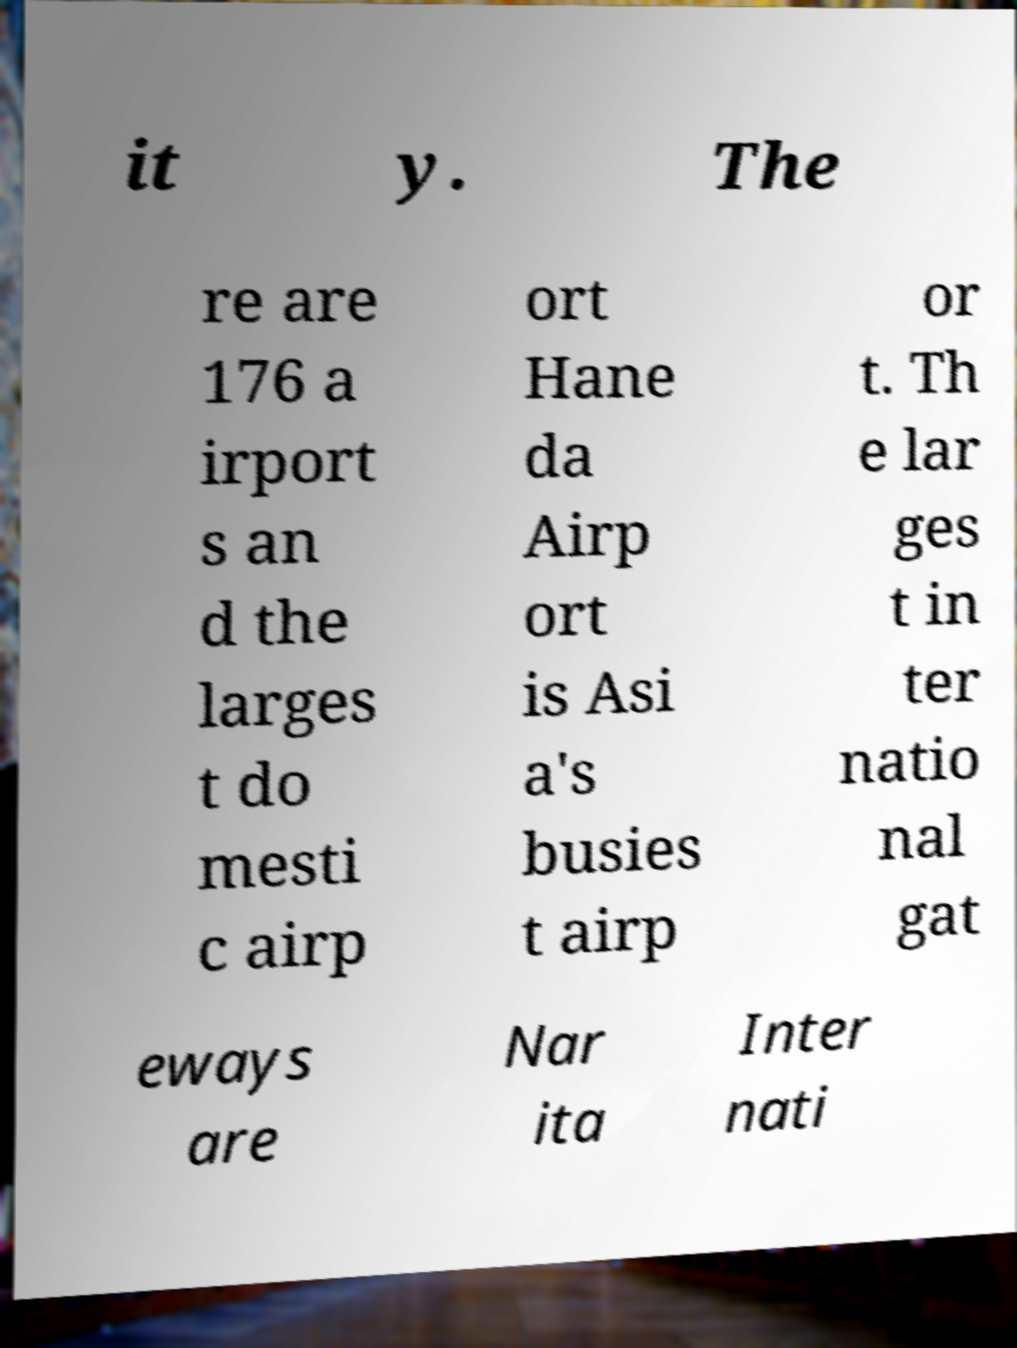Please read and relay the text visible in this image. What does it say? it y. The re are 176 a irport s an d the larges t do mesti c airp ort Hane da Airp ort is Asi a's busies t airp or t. Th e lar ges t in ter natio nal gat eways are Nar ita Inter nati 